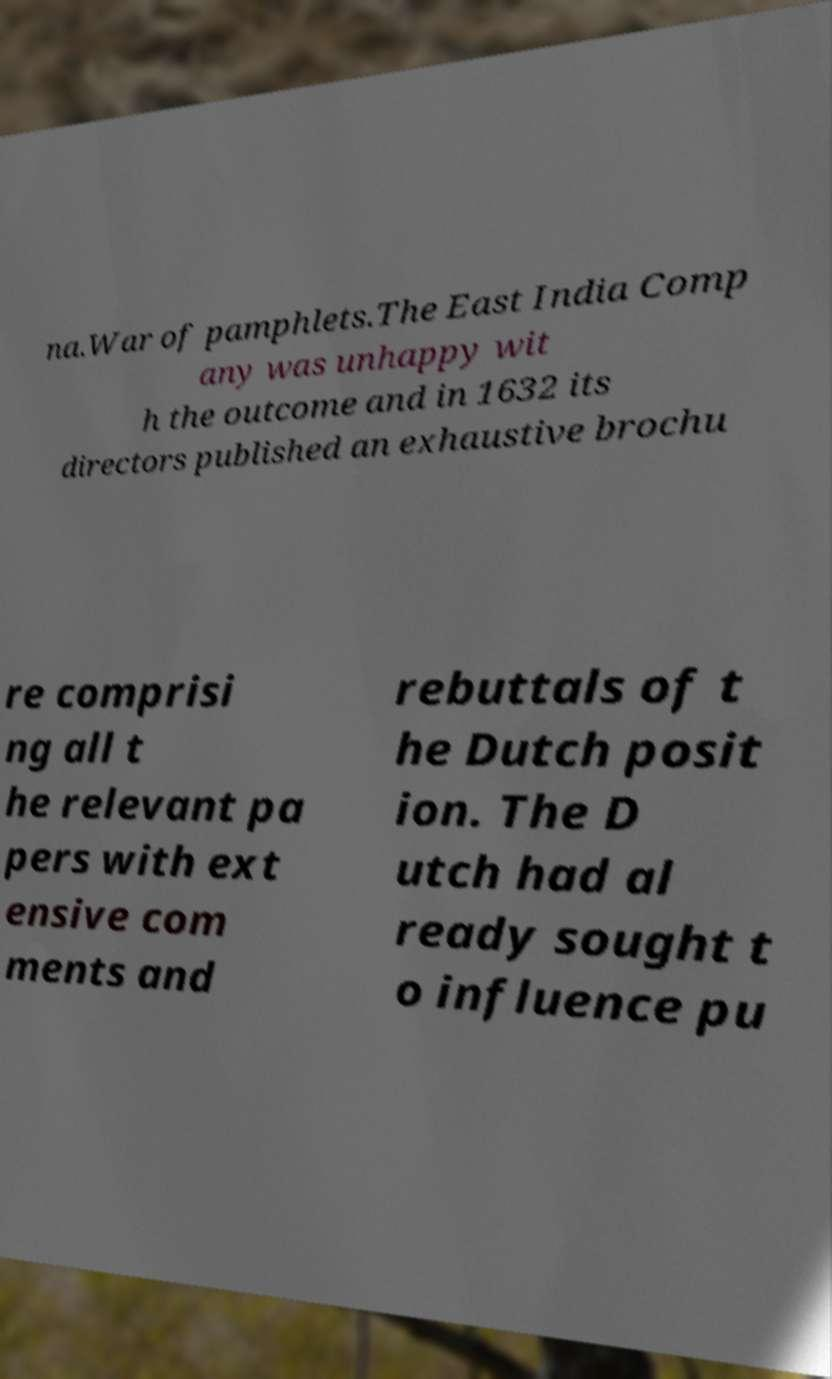For documentation purposes, I need the text within this image transcribed. Could you provide that? na.War of pamphlets.The East India Comp any was unhappy wit h the outcome and in 1632 its directors published an exhaustive brochu re comprisi ng all t he relevant pa pers with ext ensive com ments and rebuttals of t he Dutch posit ion. The D utch had al ready sought t o influence pu 